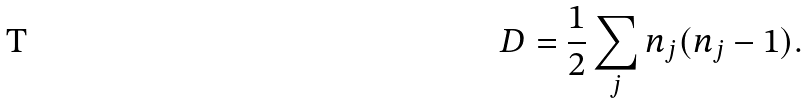Convert formula to latex. <formula><loc_0><loc_0><loc_500><loc_500>D = \frac { 1 } { 2 } \sum _ { j } n _ { j } ( n _ { j } - 1 ) .</formula> 